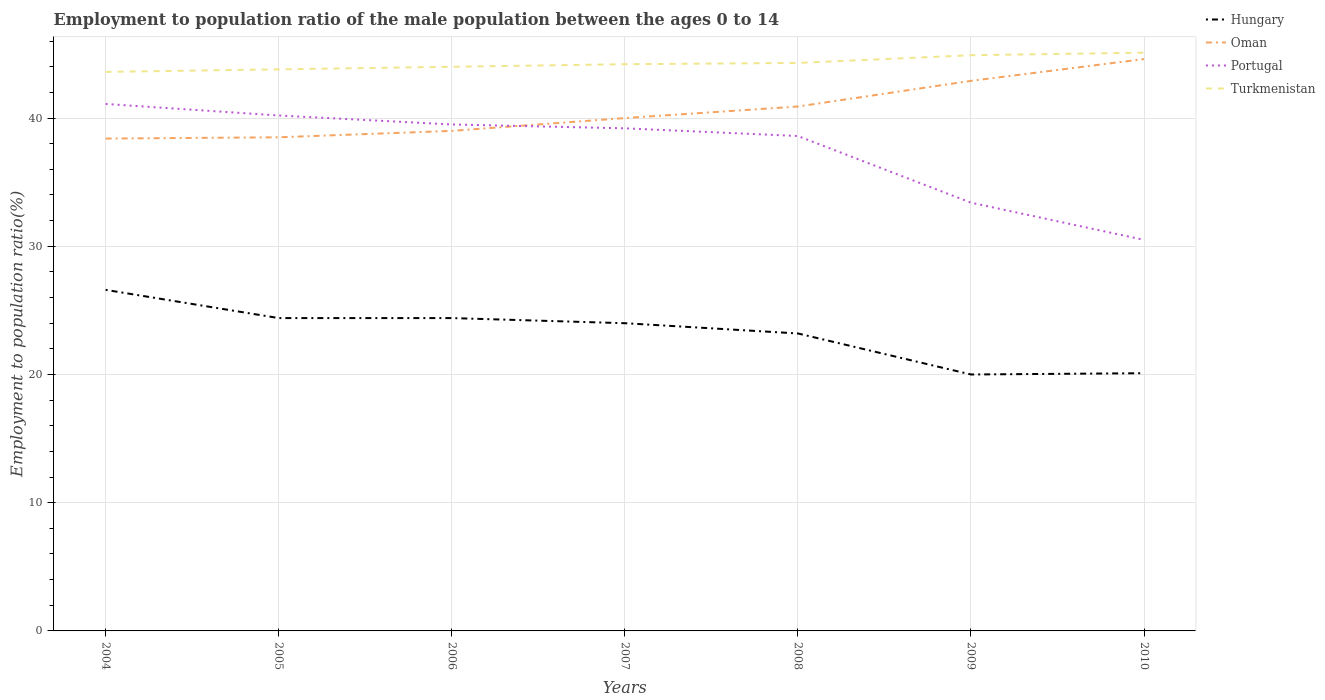How many different coloured lines are there?
Offer a terse response. 4. Does the line corresponding to Portugal intersect with the line corresponding to Turkmenistan?
Provide a succinct answer. No. Across all years, what is the maximum employment to population ratio in Hungary?
Ensure brevity in your answer.  20. In which year was the employment to population ratio in Turkmenistan maximum?
Offer a very short reply. 2004. What is the total employment to population ratio in Turkmenistan in the graph?
Provide a short and direct response. -0.6. What is the difference between the highest and the second highest employment to population ratio in Oman?
Keep it short and to the point. 6.2. How many lines are there?
Give a very brief answer. 4. What is the difference between two consecutive major ticks on the Y-axis?
Ensure brevity in your answer.  10. Are the values on the major ticks of Y-axis written in scientific E-notation?
Keep it short and to the point. No. Does the graph contain any zero values?
Provide a succinct answer. No. How are the legend labels stacked?
Provide a succinct answer. Vertical. What is the title of the graph?
Keep it short and to the point. Employment to population ratio of the male population between the ages 0 to 14. What is the label or title of the X-axis?
Offer a terse response. Years. What is the Employment to population ratio(%) in Hungary in 2004?
Give a very brief answer. 26.6. What is the Employment to population ratio(%) of Oman in 2004?
Keep it short and to the point. 38.4. What is the Employment to population ratio(%) of Portugal in 2004?
Your answer should be compact. 41.1. What is the Employment to population ratio(%) of Turkmenistan in 2004?
Ensure brevity in your answer.  43.6. What is the Employment to population ratio(%) of Hungary in 2005?
Provide a short and direct response. 24.4. What is the Employment to population ratio(%) in Oman in 2005?
Keep it short and to the point. 38.5. What is the Employment to population ratio(%) of Portugal in 2005?
Your answer should be compact. 40.2. What is the Employment to population ratio(%) in Turkmenistan in 2005?
Offer a terse response. 43.8. What is the Employment to population ratio(%) in Hungary in 2006?
Make the answer very short. 24.4. What is the Employment to population ratio(%) of Oman in 2006?
Keep it short and to the point. 39. What is the Employment to population ratio(%) in Portugal in 2006?
Offer a very short reply. 39.5. What is the Employment to population ratio(%) of Turkmenistan in 2006?
Make the answer very short. 44. What is the Employment to population ratio(%) of Oman in 2007?
Your answer should be very brief. 40. What is the Employment to population ratio(%) in Portugal in 2007?
Your answer should be compact. 39.2. What is the Employment to population ratio(%) of Turkmenistan in 2007?
Keep it short and to the point. 44.2. What is the Employment to population ratio(%) in Hungary in 2008?
Offer a very short reply. 23.2. What is the Employment to population ratio(%) in Oman in 2008?
Keep it short and to the point. 40.9. What is the Employment to population ratio(%) of Portugal in 2008?
Your answer should be compact. 38.6. What is the Employment to population ratio(%) in Turkmenistan in 2008?
Offer a terse response. 44.3. What is the Employment to population ratio(%) in Hungary in 2009?
Keep it short and to the point. 20. What is the Employment to population ratio(%) in Oman in 2009?
Give a very brief answer. 42.9. What is the Employment to population ratio(%) in Portugal in 2009?
Your answer should be very brief. 33.4. What is the Employment to population ratio(%) of Turkmenistan in 2009?
Keep it short and to the point. 44.9. What is the Employment to population ratio(%) of Hungary in 2010?
Offer a terse response. 20.1. What is the Employment to population ratio(%) in Oman in 2010?
Provide a short and direct response. 44.6. What is the Employment to population ratio(%) in Portugal in 2010?
Your response must be concise. 30.5. What is the Employment to population ratio(%) of Turkmenistan in 2010?
Keep it short and to the point. 45.1. Across all years, what is the maximum Employment to population ratio(%) in Hungary?
Keep it short and to the point. 26.6. Across all years, what is the maximum Employment to population ratio(%) in Oman?
Provide a short and direct response. 44.6. Across all years, what is the maximum Employment to population ratio(%) of Portugal?
Give a very brief answer. 41.1. Across all years, what is the maximum Employment to population ratio(%) of Turkmenistan?
Your answer should be compact. 45.1. Across all years, what is the minimum Employment to population ratio(%) in Oman?
Give a very brief answer. 38.4. Across all years, what is the minimum Employment to population ratio(%) of Portugal?
Give a very brief answer. 30.5. Across all years, what is the minimum Employment to population ratio(%) of Turkmenistan?
Provide a short and direct response. 43.6. What is the total Employment to population ratio(%) in Hungary in the graph?
Your answer should be very brief. 162.7. What is the total Employment to population ratio(%) of Oman in the graph?
Provide a succinct answer. 284.3. What is the total Employment to population ratio(%) of Portugal in the graph?
Provide a succinct answer. 262.5. What is the total Employment to population ratio(%) of Turkmenistan in the graph?
Offer a terse response. 309.9. What is the difference between the Employment to population ratio(%) of Hungary in 2004 and that in 2005?
Your response must be concise. 2.2. What is the difference between the Employment to population ratio(%) of Oman in 2004 and that in 2005?
Give a very brief answer. -0.1. What is the difference between the Employment to population ratio(%) in Turkmenistan in 2004 and that in 2005?
Give a very brief answer. -0.2. What is the difference between the Employment to population ratio(%) of Portugal in 2004 and that in 2006?
Provide a succinct answer. 1.6. What is the difference between the Employment to population ratio(%) in Turkmenistan in 2004 and that in 2006?
Your response must be concise. -0.4. What is the difference between the Employment to population ratio(%) of Hungary in 2004 and that in 2007?
Your response must be concise. 2.6. What is the difference between the Employment to population ratio(%) of Oman in 2004 and that in 2007?
Make the answer very short. -1.6. What is the difference between the Employment to population ratio(%) in Portugal in 2004 and that in 2007?
Your answer should be very brief. 1.9. What is the difference between the Employment to population ratio(%) of Turkmenistan in 2004 and that in 2007?
Offer a terse response. -0.6. What is the difference between the Employment to population ratio(%) in Hungary in 2004 and that in 2008?
Provide a short and direct response. 3.4. What is the difference between the Employment to population ratio(%) in Hungary in 2004 and that in 2009?
Your response must be concise. 6.6. What is the difference between the Employment to population ratio(%) of Oman in 2004 and that in 2009?
Your answer should be compact. -4.5. What is the difference between the Employment to population ratio(%) of Turkmenistan in 2004 and that in 2009?
Offer a very short reply. -1.3. What is the difference between the Employment to population ratio(%) in Oman in 2004 and that in 2010?
Provide a succinct answer. -6.2. What is the difference between the Employment to population ratio(%) of Portugal in 2004 and that in 2010?
Offer a terse response. 10.6. What is the difference between the Employment to population ratio(%) of Hungary in 2005 and that in 2006?
Ensure brevity in your answer.  0. What is the difference between the Employment to population ratio(%) of Turkmenistan in 2005 and that in 2006?
Ensure brevity in your answer.  -0.2. What is the difference between the Employment to population ratio(%) in Turkmenistan in 2005 and that in 2007?
Provide a succinct answer. -0.4. What is the difference between the Employment to population ratio(%) in Hungary in 2005 and that in 2008?
Offer a terse response. 1.2. What is the difference between the Employment to population ratio(%) in Hungary in 2005 and that in 2009?
Ensure brevity in your answer.  4.4. What is the difference between the Employment to population ratio(%) in Portugal in 2005 and that in 2009?
Provide a short and direct response. 6.8. What is the difference between the Employment to population ratio(%) in Oman in 2005 and that in 2010?
Provide a succinct answer. -6.1. What is the difference between the Employment to population ratio(%) of Oman in 2006 and that in 2007?
Provide a short and direct response. -1. What is the difference between the Employment to population ratio(%) of Portugal in 2006 and that in 2007?
Ensure brevity in your answer.  0.3. What is the difference between the Employment to population ratio(%) in Turkmenistan in 2006 and that in 2007?
Ensure brevity in your answer.  -0.2. What is the difference between the Employment to population ratio(%) of Hungary in 2006 and that in 2009?
Your response must be concise. 4.4. What is the difference between the Employment to population ratio(%) of Oman in 2006 and that in 2009?
Offer a terse response. -3.9. What is the difference between the Employment to population ratio(%) of Portugal in 2006 and that in 2010?
Your answer should be very brief. 9. What is the difference between the Employment to population ratio(%) in Hungary in 2007 and that in 2008?
Keep it short and to the point. 0.8. What is the difference between the Employment to population ratio(%) in Hungary in 2007 and that in 2009?
Give a very brief answer. 4. What is the difference between the Employment to population ratio(%) of Oman in 2007 and that in 2009?
Ensure brevity in your answer.  -2.9. What is the difference between the Employment to population ratio(%) in Portugal in 2007 and that in 2009?
Provide a succinct answer. 5.8. What is the difference between the Employment to population ratio(%) of Turkmenistan in 2007 and that in 2009?
Provide a succinct answer. -0.7. What is the difference between the Employment to population ratio(%) of Hungary in 2007 and that in 2010?
Offer a terse response. 3.9. What is the difference between the Employment to population ratio(%) in Hungary in 2008 and that in 2009?
Provide a succinct answer. 3.2. What is the difference between the Employment to population ratio(%) in Portugal in 2008 and that in 2009?
Make the answer very short. 5.2. What is the difference between the Employment to population ratio(%) in Turkmenistan in 2008 and that in 2009?
Your answer should be very brief. -0.6. What is the difference between the Employment to population ratio(%) of Oman in 2008 and that in 2010?
Offer a very short reply. -3.7. What is the difference between the Employment to population ratio(%) of Hungary in 2004 and the Employment to population ratio(%) of Turkmenistan in 2005?
Offer a terse response. -17.2. What is the difference between the Employment to population ratio(%) in Portugal in 2004 and the Employment to population ratio(%) in Turkmenistan in 2005?
Ensure brevity in your answer.  -2.7. What is the difference between the Employment to population ratio(%) in Hungary in 2004 and the Employment to population ratio(%) in Portugal in 2006?
Your answer should be compact. -12.9. What is the difference between the Employment to population ratio(%) of Hungary in 2004 and the Employment to population ratio(%) of Turkmenistan in 2006?
Offer a very short reply. -17.4. What is the difference between the Employment to population ratio(%) of Portugal in 2004 and the Employment to population ratio(%) of Turkmenistan in 2006?
Your answer should be compact. -2.9. What is the difference between the Employment to population ratio(%) in Hungary in 2004 and the Employment to population ratio(%) in Portugal in 2007?
Your response must be concise. -12.6. What is the difference between the Employment to population ratio(%) in Hungary in 2004 and the Employment to population ratio(%) in Turkmenistan in 2007?
Provide a short and direct response. -17.6. What is the difference between the Employment to population ratio(%) in Portugal in 2004 and the Employment to population ratio(%) in Turkmenistan in 2007?
Make the answer very short. -3.1. What is the difference between the Employment to population ratio(%) in Hungary in 2004 and the Employment to population ratio(%) in Oman in 2008?
Your answer should be compact. -14.3. What is the difference between the Employment to population ratio(%) of Hungary in 2004 and the Employment to population ratio(%) of Portugal in 2008?
Give a very brief answer. -12. What is the difference between the Employment to population ratio(%) of Hungary in 2004 and the Employment to population ratio(%) of Turkmenistan in 2008?
Your response must be concise. -17.7. What is the difference between the Employment to population ratio(%) of Oman in 2004 and the Employment to population ratio(%) of Portugal in 2008?
Your answer should be compact. -0.2. What is the difference between the Employment to population ratio(%) in Oman in 2004 and the Employment to population ratio(%) in Turkmenistan in 2008?
Offer a terse response. -5.9. What is the difference between the Employment to population ratio(%) of Hungary in 2004 and the Employment to population ratio(%) of Oman in 2009?
Make the answer very short. -16.3. What is the difference between the Employment to population ratio(%) in Hungary in 2004 and the Employment to population ratio(%) in Portugal in 2009?
Make the answer very short. -6.8. What is the difference between the Employment to population ratio(%) in Hungary in 2004 and the Employment to population ratio(%) in Turkmenistan in 2009?
Your answer should be very brief. -18.3. What is the difference between the Employment to population ratio(%) of Hungary in 2004 and the Employment to population ratio(%) of Oman in 2010?
Give a very brief answer. -18. What is the difference between the Employment to population ratio(%) of Hungary in 2004 and the Employment to population ratio(%) of Turkmenistan in 2010?
Offer a terse response. -18.5. What is the difference between the Employment to population ratio(%) in Oman in 2004 and the Employment to population ratio(%) in Portugal in 2010?
Your response must be concise. 7.9. What is the difference between the Employment to population ratio(%) of Portugal in 2004 and the Employment to population ratio(%) of Turkmenistan in 2010?
Your response must be concise. -4. What is the difference between the Employment to population ratio(%) of Hungary in 2005 and the Employment to population ratio(%) of Oman in 2006?
Make the answer very short. -14.6. What is the difference between the Employment to population ratio(%) of Hungary in 2005 and the Employment to population ratio(%) of Portugal in 2006?
Give a very brief answer. -15.1. What is the difference between the Employment to population ratio(%) of Hungary in 2005 and the Employment to population ratio(%) of Turkmenistan in 2006?
Your answer should be very brief. -19.6. What is the difference between the Employment to population ratio(%) of Oman in 2005 and the Employment to population ratio(%) of Portugal in 2006?
Give a very brief answer. -1. What is the difference between the Employment to population ratio(%) of Hungary in 2005 and the Employment to population ratio(%) of Oman in 2007?
Your answer should be compact. -15.6. What is the difference between the Employment to population ratio(%) of Hungary in 2005 and the Employment to population ratio(%) of Portugal in 2007?
Ensure brevity in your answer.  -14.8. What is the difference between the Employment to population ratio(%) in Hungary in 2005 and the Employment to population ratio(%) in Turkmenistan in 2007?
Keep it short and to the point. -19.8. What is the difference between the Employment to population ratio(%) in Hungary in 2005 and the Employment to population ratio(%) in Oman in 2008?
Make the answer very short. -16.5. What is the difference between the Employment to population ratio(%) in Hungary in 2005 and the Employment to population ratio(%) in Turkmenistan in 2008?
Offer a very short reply. -19.9. What is the difference between the Employment to population ratio(%) in Oman in 2005 and the Employment to population ratio(%) in Portugal in 2008?
Offer a very short reply. -0.1. What is the difference between the Employment to population ratio(%) in Oman in 2005 and the Employment to population ratio(%) in Turkmenistan in 2008?
Provide a short and direct response. -5.8. What is the difference between the Employment to population ratio(%) in Hungary in 2005 and the Employment to population ratio(%) in Oman in 2009?
Ensure brevity in your answer.  -18.5. What is the difference between the Employment to population ratio(%) in Hungary in 2005 and the Employment to population ratio(%) in Turkmenistan in 2009?
Provide a short and direct response. -20.5. What is the difference between the Employment to population ratio(%) of Oman in 2005 and the Employment to population ratio(%) of Portugal in 2009?
Ensure brevity in your answer.  5.1. What is the difference between the Employment to population ratio(%) in Oman in 2005 and the Employment to population ratio(%) in Turkmenistan in 2009?
Ensure brevity in your answer.  -6.4. What is the difference between the Employment to population ratio(%) in Portugal in 2005 and the Employment to population ratio(%) in Turkmenistan in 2009?
Make the answer very short. -4.7. What is the difference between the Employment to population ratio(%) in Hungary in 2005 and the Employment to population ratio(%) in Oman in 2010?
Give a very brief answer. -20.2. What is the difference between the Employment to population ratio(%) in Hungary in 2005 and the Employment to population ratio(%) in Turkmenistan in 2010?
Your answer should be very brief. -20.7. What is the difference between the Employment to population ratio(%) of Oman in 2005 and the Employment to population ratio(%) of Turkmenistan in 2010?
Make the answer very short. -6.6. What is the difference between the Employment to population ratio(%) of Portugal in 2005 and the Employment to population ratio(%) of Turkmenistan in 2010?
Your answer should be compact. -4.9. What is the difference between the Employment to population ratio(%) in Hungary in 2006 and the Employment to population ratio(%) in Oman in 2007?
Your response must be concise. -15.6. What is the difference between the Employment to population ratio(%) in Hungary in 2006 and the Employment to population ratio(%) in Portugal in 2007?
Your answer should be very brief. -14.8. What is the difference between the Employment to population ratio(%) of Hungary in 2006 and the Employment to population ratio(%) of Turkmenistan in 2007?
Your answer should be compact. -19.8. What is the difference between the Employment to population ratio(%) in Oman in 2006 and the Employment to population ratio(%) in Turkmenistan in 2007?
Provide a short and direct response. -5.2. What is the difference between the Employment to population ratio(%) of Portugal in 2006 and the Employment to population ratio(%) of Turkmenistan in 2007?
Offer a very short reply. -4.7. What is the difference between the Employment to population ratio(%) of Hungary in 2006 and the Employment to population ratio(%) of Oman in 2008?
Your response must be concise. -16.5. What is the difference between the Employment to population ratio(%) in Hungary in 2006 and the Employment to population ratio(%) in Portugal in 2008?
Offer a very short reply. -14.2. What is the difference between the Employment to population ratio(%) in Hungary in 2006 and the Employment to population ratio(%) in Turkmenistan in 2008?
Your answer should be compact. -19.9. What is the difference between the Employment to population ratio(%) of Oman in 2006 and the Employment to population ratio(%) of Portugal in 2008?
Provide a short and direct response. 0.4. What is the difference between the Employment to population ratio(%) of Oman in 2006 and the Employment to population ratio(%) of Turkmenistan in 2008?
Provide a succinct answer. -5.3. What is the difference between the Employment to population ratio(%) in Portugal in 2006 and the Employment to population ratio(%) in Turkmenistan in 2008?
Offer a terse response. -4.8. What is the difference between the Employment to population ratio(%) of Hungary in 2006 and the Employment to population ratio(%) of Oman in 2009?
Keep it short and to the point. -18.5. What is the difference between the Employment to population ratio(%) in Hungary in 2006 and the Employment to population ratio(%) in Portugal in 2009?
Your response must be concise. -9. What is the difference between the Employment to population ratio(%) of Hungary in 2006 and the Employment to population ratio(%) of Turkmenistan in 2009?
Your answer should be very brief. -20.5. What is the difference between the Employment to population ratio(%) of Oman in 2006 and the Employment to population ratio(%) of Portugal in 2009?
Provide a short and direct response. 5.6. What is the difference between the Employment to population ratio(%) in Oman in 2006 and the Employment to population ratio(%) in Turkmenistan in 2009?
Provide a short and direct response. -5.9. What is the difference between the Employment to population ratio(%) of Hungary in 2006 and the Employment to population ratio(%) of Oman in 2010?
Your answer should be compact. -20.2. What is the difference between the Employment to population ratio(%) of Hungary in 2006 and the Employment to population ratio(%) of Turkmenistan in 2010?
Provide a short and direct response. -20.7. What is the difference between the Employment to population ratio(%) in Oman in 2006 and the Employment to population ratio(%) in Portugal in 2010?
Give a very brief answer. 8.5. What is the difference between the Employment to population ratio(%) in Oman in 2006 and the Employment to population ratio(%) in Turkmenistan in 2010?
Your answer should be very brief. -6.1. What is the difference between the Employment to population ratio(%) of Portugal in 2006 and the Employment to population ratio(%) of Turkmenistan in 2010?
Give a very brief answer. -5.6. What is the difference between the Employment to population ratio(%) in Hungary in 2007 and the Employment to population ratio(%) in Oman in 2008?
Your answer should be compact. -16.9. What is the difference between the Employment to population ratio(%) of Hungary in 2007 and the Employment to population ratio(%) of Portugal in 2008?
Make the answer very short. -14.6. What is the difference between the Employment to population ratio(%) of Hungary in 2007 and the Employment to population ratio(%) of Turkmenistan in 2008?
Give a very brief answer. -20.3. What is the difference between the Employment to population ratio(%) in Portugal in 2007 and the Employment to population ratio(%) in Turkmenistan in 2008?
Make the answer very short. -5.1. What is the difference between the Employment to population ratio(%) of Hungary in 2007 and the Employment to population ratio(%) of Oman in 2009?
Provide a short and direct response. -18.9. What is the difference between the Employment to population ratio(%) of Hungary in 2007 and the Employment to population ratio(%) of Portugal in 2009?
Keep it short and to the point. -9.4. What is the difference between the Employment to population ratio(%) of Hungary in 2007 and the Employment to population ratio(%) of Turkmenistan in 2009?
Make the answer very short. -20.9. What is the difference between the Employment to population ratio(%) in Oman in 2007 and the Employment to population ratio(%) in Portugal in 2009?
Offer a very short reply. 6.6. What is the difference between the Employment to population ratio(%) in Oman in 2007 and the Employment to population ratio(%) in Turkmenistan in 2009?
Ensure brevity in your answer.  -4.9. What is the difference between the Employment to population ratio(%) in Hungary in 2007 and the Employment to population ratio(%) in Oman in 2010?
Offer a terse response. -20.6. What is the difference between the Employment to population ratio(%) of Hungary in 2007 and the Employment to population ratio(%) of Portugal in 2010?
Make the answer very short. -6.5. What is the difference between the Employment to population ratio(%) in Hungary in 2007 and the Employment to population ratio(%) in Turkmenistan in 2010?
Ensure brevity in your answer.  -21.1. What is the difference between the Employment to population ratio(%) in Oman in 2007 and the Employment to population ratio(%) in Turkmenistan in 2010?
Offer a terse response. -5.1. What is the difference between the Employment to population ratio(%) in Portugal in 2007 and the Employment to population ratio(%) in Turkmenistan in 2010?
Your answer should be very brief. -5.9. What is the difference between the Employment to population ratio(%) of Hungary in 2008 and the Employment to population ratio(%) of Oman in 2009?
Provide a succinct answer. -19.7. What is the difference between the Employment to population ratio(%) of Hungary in 2008 and the Employment to population ratio(%) of Turkmenistan in 2009?
Provide a short and direct response. -21.7. What is the difference between the Employment to population ratio(%) in Portugal in 2008 and the Employment to population ratio(%) in Turkmenistan in 2009?
Provide a short and direct response. -6.3. What is the difference between the Employment to population ratio(%) of Hungary in 2008 and the Employment to population ratio(%) of Oman in 2010?
Provide a short and direct response. -21.4. What is the difference between the Employment to population ratio(%) in Hungary in 2008 and the Employment to population ratio(%) in Portugal in 2010?
Your answer should be very brief. -7.3. What is the difference between the Employment to population ratio(%) in Hungary in 2008 and the Employment to population ratio(%) in Turkmenistan in 2010?
Provide a succinct answer. -21.9. What is the difference between the Employment to population ratio(%) in Oman in 2008 and the Employment to population ratio(%) in Portugal in 2010?
Keep it short and to the point. 10.4. What is the difference between the Employment to population ratio(%) of Oman in 2008 and the Employment to population ratio(%) of Turkmenistan in 2010?
Your response must be concise. -4.2. What is the difference between the Employment to population ratio(%) in Hungary in 2009 and the Employment to population ratio(%) in Oman in 2010?
Ensure brevity in your answer.  -24.6. What is the difference between the Employment to population ratio(%) of Hungary in 2009 and the Employment to population ratio(%) of Portugal in 2010?
Your response must be concise. -10.5. What is the difference between the Employment to population ratio(%) in Hungary in 2009 and the Employment to population ratio(%) in Turkmenistan in 2010?
Offer a very short reply. -25.1. What is the average Employment to population ratio(%) of Hungary per year?
Make the answer very short. 23.24. What is the average Employment to population ratio(%) of Oman per year?
Offer a terse response. 40.61. What is the average Employment to population ratio(%) in Portugal per year?
Offer a very short reply. 37.5. What is the average Employment to population ratio(%) of Turkmenistan per year?
Your response must be concise. 44.27. In the year 2004, what is the difference between the Employment to population ratio(%) in Hungary and Employment to population ratio(%) in Oman?
Provide a succinct answer. -11.8. In the year 2004, what is the difference between the Employment to population ratio(%) in Oman and Employment to population ratio(%) in Portugal?
Provide a succinct answer. -2.7. In the year 2004, what is the difference between the Employment to population ratio(%) in Portugal and Employment to population ratio(%) in Turkmenistan?
Provide a succinct answer. -2.5. In the year 2005, what is the difference between the Employment to population ratio(%) in Hungary and Employment to population ratio(%) in Oman?
Your response must be concise. -14.1. In the year 2005, what is the difference between the Employment to population ratio(%) in Hungary and Employment to population ratio(%) in Portugal?
Your response must be concise. -15.8. In the year 2005, what is the difference between the Employment to population ratio(%) of Hungary and Employment to population ratio(%) of Turkmenistan?
Provide a short and direct response. -19.4. In the year 2005, what is the difference between the Employment to population ratio(%) in Portugal and Employment to population ratio(%) in Turkmenistan?
Your answer should be compact. -3.6. In the year 2006, what is the difference between the Employment to population ratio(%) of Hungary and Employment to population ratio(%) of Oman?
Make the answer very short. -14.6. In the year 2006, what is the difference between the Employment to population ratio(%) of Hungary and Employment to population ratio(%) of Portugal?
Your answer should be very brief. -15.1. In the year 2006, what is the difference between the Employment to population ratio(%) in Hungary and Employment to population ratio(%) in Turkmenistan?
Keep it short and to the point. -19.6. In the year 2006, what is the difference between the Employment to population ratio(%) in Oman and Employment to population ratio(%) in Turkmenistan?
Offer a very short reply. -5. In the year 2007, what is the difference between the Employment to population ratio(%) of Hungary and Employment to population ratio(%) of Portugal?
Your response must be concise. -15.2. In the year 2007, what is the difference between the Employment to population ratio(%) of Hungary and Employment to population ratio(%) of Turkmenistan?
Offer a very short reply. -20.2. In the year 2008, what is the difference between the Employment to population ratio(%) in Hungary and Employment to population ratio(%) in Oman?
Provide a succinct answer. -17.7. In the year 2008, what is the difference between the Employment to population ratio(%) in Hungary and Employment to population ratio(%) in Portugal?
Offer a very short reply. -15.4. In the year 2008, what is the difference between the Employment to population ratio(%) in Hungary and Employment to population ratio(%) in Turkmenistan?
Offer a very short reply. -21.1. In the year 2009, what is the difference between the Employment to population ratio(%) of Hungary and Employment to population ratio(%) of Oman?
Ensure brevity in your answer.  -22.9. In the year 2009, what is the difference between the Employment to population ratio(%) of Hungary and Employment to population ratio(%) of Portugal?
Provide a short and direct response. -13.4. In the year 2009, what is the difference between the Employment to population ratio(%) of Hungary and Employment to population ratio(%) of Turkmenistan?
Your answer should be compact. -24.9. In the year 2009, what is the difference between the Employment to population ratio(%) of Oman and Employment to population ratio(%) of Turkmenistan?
Your response must be concise. -2. In the year 2009, what is the difference between the Employment to population ratio(%) of Portugal and Employment to population ratio(%) of Turkmenistan?
Offer a very short reply. -11.5. In the year 2010, what is the difference between the Employment to population ratio(%) in Hungary and Employment to population ratio(%) in Oman?
Your answer should be very brief. -24.5. In the year 2010, what is the difference between the Employment to population ratio(%) of Hungary and Employment to population ratio(%) of Turkmenistan?
Your answer should be compact. -25. In the year 2010, what is the difference between the Employment to population ratio(%) in Oman and Employment to population ratio(%) in Portugal?
Offer a very short reply. 14.1. In the year 2010, what is the difference between the Employment to population ratio(%) of Portugal and Employment to population ratio(%) of Turkmenistan?
Keep it short and to the point. -14.6. What is the ratio of the Employment to population ratio(%) in Hungary in 2004 to that in 2005?
Your answer should be very brief. 1.09. What is the ratio of the Employment to population ratio(%) in Portugal in 2004 to that in 2005?
Provide a succinct answer. 1.02. What is the ratio of the Employment to population ratio(%) of Hungary in 2004 to that in 2006?
Provide a succinct answer. 1.09. What is the ratio of the Employment to population ratio(%) of Oman in 2004 to that in 2006?
Provide a succinct answer. 0.98. What is the ratio of the Employment to population ratio(%) in Portugal in 2004 to that in 2006?
Keep it short and to the point. 1.04. What is the ratio of the Employment to population ratio(%) in Turkmenistan in 2004 to that in 2006?
Give a very brief answer. 0.99. What is the ratio of the Employment to population ratio(%) of Hungary in 2004 to that in 2007?
Your response must be concise. 1.11. What is the ratio of the Employment to population ratio(%) in Portugal in 2004 to that in 2007?
Make the answer very short. 1.05. What is the ratio of the Employment to population ratio(%) in Turkmenistan in 2004 to that in 2007?
Offer a terse response. 0.99. What is the ratio of the Employment to population ratio(%) of Hungary in 2004 to that in 2008?
Keep it short and to the point. 1.15. What is the ratio of the Employment to population ratio(%) in Oman in 2004 to that in 2008?
Keep it short and to the point. 0.94. What is the ratio of the Employment to population ratio(%) of Portugal in 2004 to that in 2008?
Your answer should be compact. 1.06. What is the ratio of the Employment to population ratio(%) in Turkmenistan in 2004 to that in 2008?
Provide a succinct answer. 0.98. What is the ratio of the Employment to population ratio(%) in Hungary in 2004 to that in 2009?
Offer a terse response. 1.33. What is the ratio of the Employment to population ratio(%) of Oman in 2004 to that in 2009?
Keep it short and to the point. 0.9. What is the ratio of the Employment to population ratio(%) of Portugal in 2004 to that in 2009?
Provide a succinct answer. 1.23. What is the ratio of the Employment to population ratio(%) of Hungary in 2004 to that in 2010?
Your answer should be compact. 1.32. What is the ratio of the Employment to population ratio(%) in Oman in 2004 to that in 2010?
Ensure brevity in your answer.  0.86. What is the ratio of the Employment to population ratio(%) of Portugal in 2004 to that in 2010?
Provide a short and direct response. 1.35. What is the ratio of the Employment to population ratio(%) in Turkmenistan in 2004 to that in 2010?
Your response must be concise. 0.97. What is the ratio of the Employment to population ratio(%) in Hungary in 2005 to that in 2006?
Offer a very short reply. 1. What is the ratio of the Employment to population ratio(%) of Oman in 2005 to that in 2006?
Keep it short and to the point. 0.99. What is the ratio of the Employment to population ratio(%) of Portugal in 2005 to that in 2006?
Offer a terse response. 1.02. What is the ratio of the Employment to population ratio(%) of Turkmenistan in 2005 to that in 2006?
Provide a succinct answer. 1. What is the ratio of the Employment to population ratio(%) of Hungary in 2005 to that in 2007?
Your response must be concise. 1.02. What is the ratio of the Employment to population ratio(%) in Oman in 2005 to that in 2007?
Ensure brevity in your answer.  0.96. What is the ratio of the Employment to population ratio(%) of Portugal in 2005 to that in 2007?
Ensure brevity in your answer.  1.03. What is the ratio of the Employment to population ratio(%) in Hungary in 2005 to that in 2008?
Ensure brevity in your answer.  1.05. What is the ratio of the Employment to population ratio(%) in Oman in 2005 to that in 2008?
Offer a terse response. 0.94. What is the ratio of the Employment to population ratio(%) in Portugal in 2005 to that in 2008?
Your response must be concise. 1.04. What is the ratio of the Employment to population ratio(%) of Turkmenistan in 2005 to that in 2008?
Provide a short and direct response. 0.99. What is the ratio of the Employment to population ratio(%) in Hungary in 2005 to that in 2009?
Ensure brevity in your answer.  1.22. What is the ratio of the Employment to population ratio(%) of Oman in 2005 to that in 2009?
Offer a terse response. 0.9. What is the ratio of the Employment to population ratio(%) of Portugal in 2005 to that in 2009?
Your response must be concise. 1.2. What is the ratio of the Employment to population ratio(%) in Turkmenistan in 2005 to that in 2009?
Your answer should be compact. 0.98. What is the ratio of the Employment to population ratio(%) in Hungary in 2005 to that in 2010?
Your answer should be very brief. 1.21. What is the ratio of the Employment to population ratio(%) of Oman in 2005 to that in 2010?
Your answer should be very brief. 0.86. What is the ratio of the Employment to population ratio(%) in Portugal in 2005 to that in 2010?
Make the answer very short. 1.32. What is the ratio of the Employment to population ratio(%) in Turkmenistan in 2005 to that in 2010?
Provide a succinct answer. 0.97. What is the ratio of the Employment to population ratio(%) of Hungary in 2006 to that in 2007?
Provide a short and direct response. 1.02. What is the ratio of the Employment to population ratio(%) in Portugal in 2006 to that in 2007?
Give a very brief answer. 1.01. What is the ratio of the Employment to population ratio(%) in Hungary in 2006 to that in 2008?
Your answer should be very brief. 1.05. What is the ratio of the Employment to population ratio(%) of Oman in 2006 to that in 2008?
Ensure brevity in your answer.  0.95. What is the ratio of the Employment to population ratio(%) in Portugal in 2006 to that in 2008?
Provide a short and direct response. 1.02. What is the ratio of the Employment to population ratio(%) in Turkmenistan in 2006 to that in 2008?
Give a very brief answer. 0.99. What is the ratio of the Employment to population ratio(%) of Hungary in 2006 to that in 2009?
Provide a succinct answer. 1.22. What is the ratio of the Employment to population ratio(%) of Portugal in 2006 to that in 2009?
Make the answer very short. 1.18. What is the ratio of the Employment to population ratio(%) of Hungary in 2006 to that in 2010?
Provide a short and direct response. 1.21. What is the ratio of the Employment to population ratio(%) of Oman in 2006 to that in 2010?
Make the answer very short. 0.87. What is the ratio of the Employment to population ratio(%) in Portugal in 2006 to that in 2010?
Provide a succinct answer. 1.3. What is the ratio of the Employment to population ratio(%) in Turkmenistan in 2006 to that in 2010?
Provide a succinct answer. 0.98. What is the ratio of the Employment to population ratio(%) of Hungary in 2007 to that in 2008?
Keep it short and to the point. 1.03. What is the ratio of the Employment to population ratio(%) of Oman in 2007 to that in 2008?
Provide a succinct answer. 0.98. What is the ratio of the Employment to population ratio(%) of Portugal in 2007 to that in 2008?
Ensure brevity in your answer.  1.02. What is the ratio of the Employment to population ratio(%) in Hungary in 2007 to that in 2009?
Keep it short and to the point. 1.2. What is the ratio of the Employment to population ratio(%) in Oman in 2007 to that in 2009?
Make the answer very short. 0.93. What is the ratio of the Employment to population ratio(%) in Portugal in 2007 to that in 2009?
Provide a short and direct response. 1.17. What is the ratio of the Employment to population ratio(%) in Turkmenistan in 2007 to that in 2009?
Offer a terse response. 0.98. What is the ratio of the Employment to population ratio(%) in Hungary in 2007 to that in 2010?
Provide a short and direct response. 1.19. What is the ratio of the Employment to population ratio(%) of Oman in 2007 to that in 2010?
Your response must be concise. 0.9. What is the ratio of the Employment to population ratio(%) in Portugal in 2007 to that in 2010?
Your answer should be compact. 1.29. What is the ratio of the Employment to population ratio(%) of Hungary in 2008 to that in 2009?
Your response must be concise. 1.16. What is the ratio of the Employment to population ratio(%) of Oman in 2008 to that in 2009?
Offer a terse response. 0.95. What is the ratio of the Employment to population ratio(%) of Portugal in 2008 to that in 2009?
Keep it short and to the point. 1.16. What is the ratio of the Employment to population ratio(%) in Turkmenistan in 2008 to that in 2009?
Provide a succinct answer. 0.99. What is the ratio of the Employment to population ratio(%) in Hungary in 2008 to that in 2010?
Give a very brief answer. 1.15. What is the ratio of the Employment to population ratio(%) in Oman in 2008 to that in 2010?
Your answer should be compact. 0.92. What is the ratio of the Employment to population ratio(%) in Portugal in 2008 to that in 2010?
Give a very brief answer. 1.27. What is the ratio of the Employment to population ratio(%) of Turkmenistan in 2008 to that in 2010?
Provide a short and direct response. 0.98. What is the ratio of the Employment to population ratio(%) in Hungary in 2009 to that in 2010?
Give a very brief answer. 0.99. What is the ratio of the Employment to population ratio(%) of Oman in 2009 to that in 2010?
Offer a terse response. 0.96. What is the ratio of the Employment to population ratio(%) in Portugal in 2009 to that in 2010?
Ensure brevity in your answer.  1.1. What is the difference between the highest and the second highest Employment to population ratio(%) in Hungary?
Offer a terse response. 2.2. What is the difference between the highest and the second highest Employment to population ratio(%) of Portugal?
Offer a very short reply. 0.9. What is the difference between the highest and the lowest Employment to population ratio(%) of Hungary?
Provide a succinct answer. 6.6. What is the difference between the highest and the lowest Employment to population ratio(%) of Oman?
Keep it short and to the point. 6.2. What is the difference between the highest and the lowest Employment to population ratio(%) of Turkmenistan?
Make the answer very short. 1.5. 